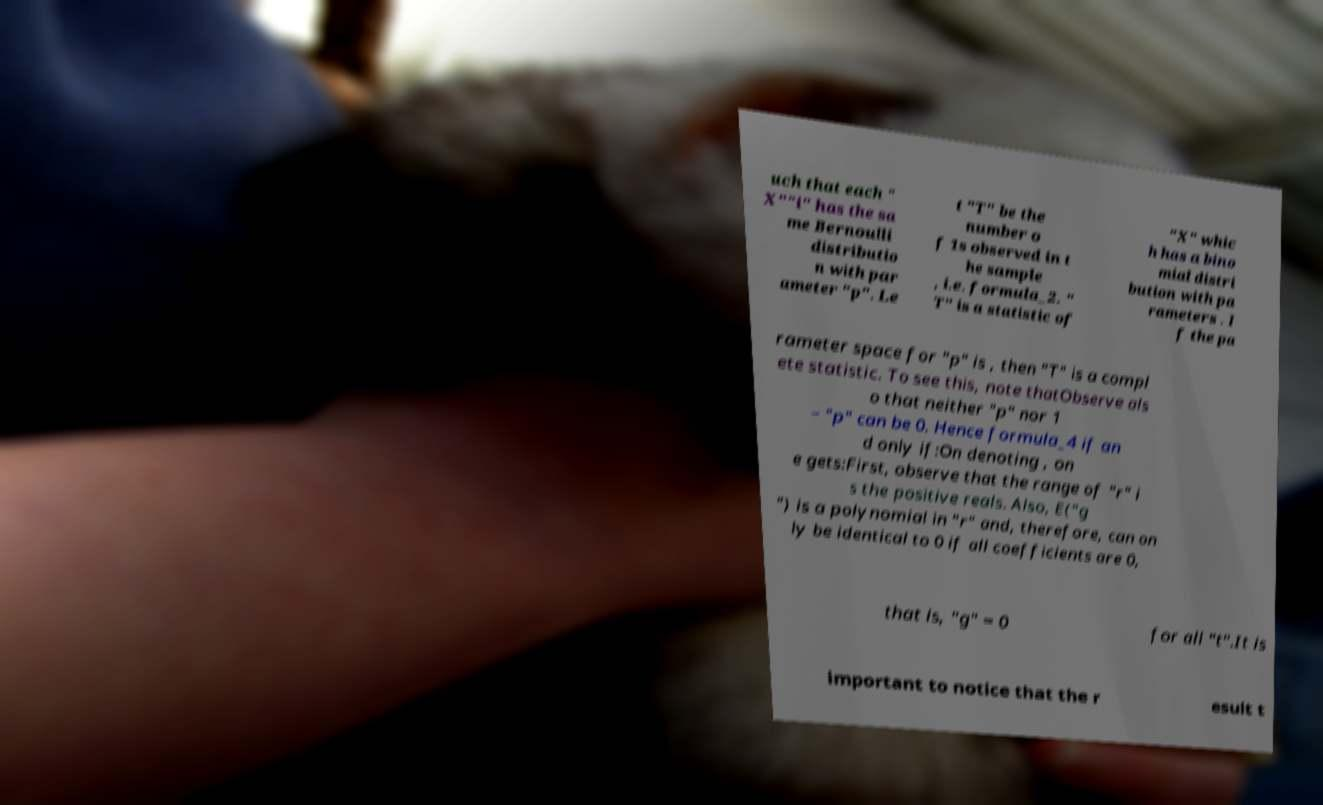Please read and relay the text visible in this image. What does it say? uch that each " X""i" has the sa me Bernoulli distributio n with par ameter "p". Le t "T" be the number o f 1s observed in t he sample , i.e. formula_2. " T" is a statistic of "X" whic h has a bino mial distri bution with pa rameters . I f the pa rameter space for "p" is , then "T" is a compl ete statistic. To see this, note thatObserve als o that neither "p" nor 1 − "p" can be 0. Hence formula_4 if an d only if:On denoting , on e gets:First, observe that the range of "r" i s the positive reals. Also, E("g ") is a polynomial in "r" and, therefore, can on ly be identical to 0 if all coefficients are 0, that is, "g" = 0 for all "t".It is important to notice that the r esult t 